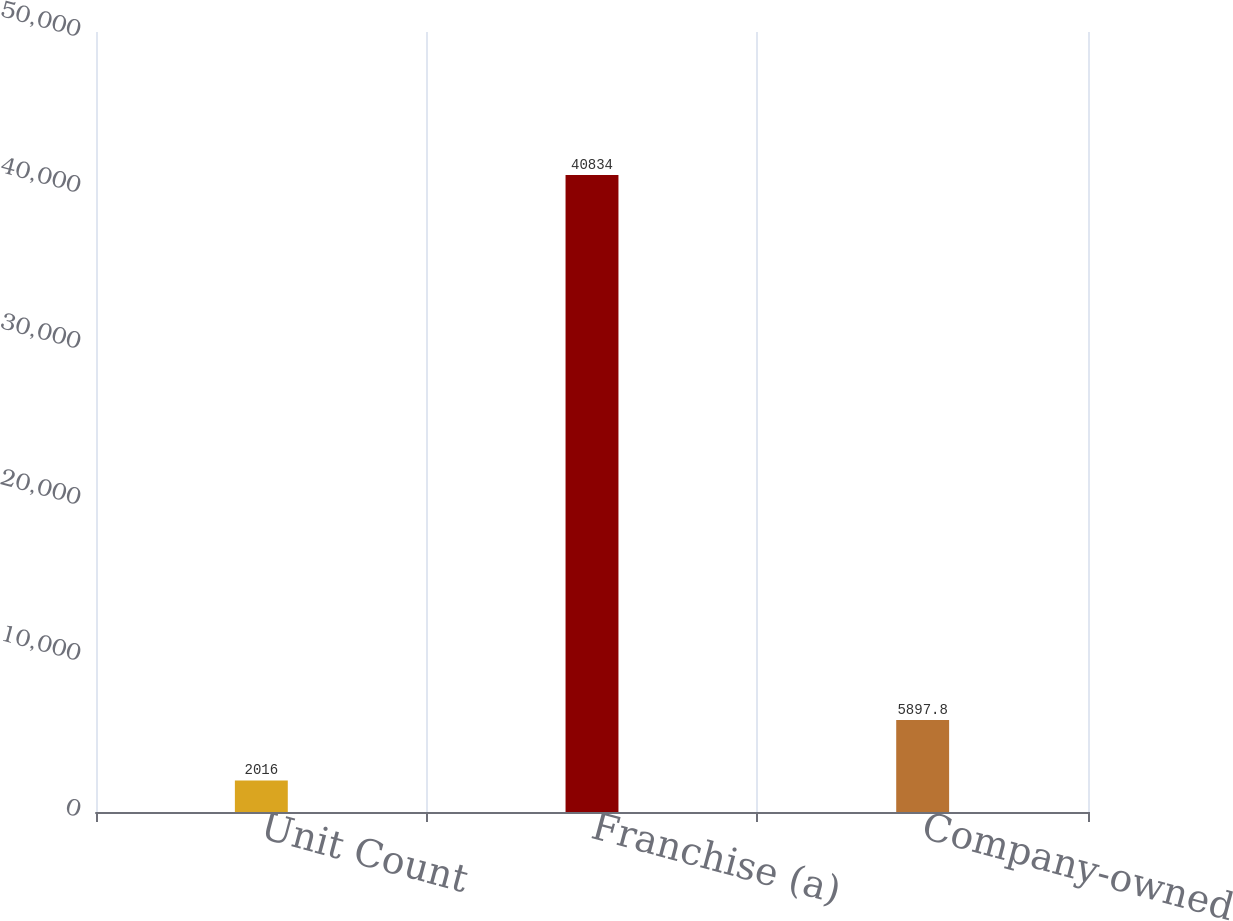<chart> <loc_0><loc_0><loc_500><loc_500><bar_chart><fcel>Unit Count<fcel>Franchise (a)<fcel>Company-owned<nl><fcel>2016<fcel>40834<fcel>5897.8<nl></chart> 